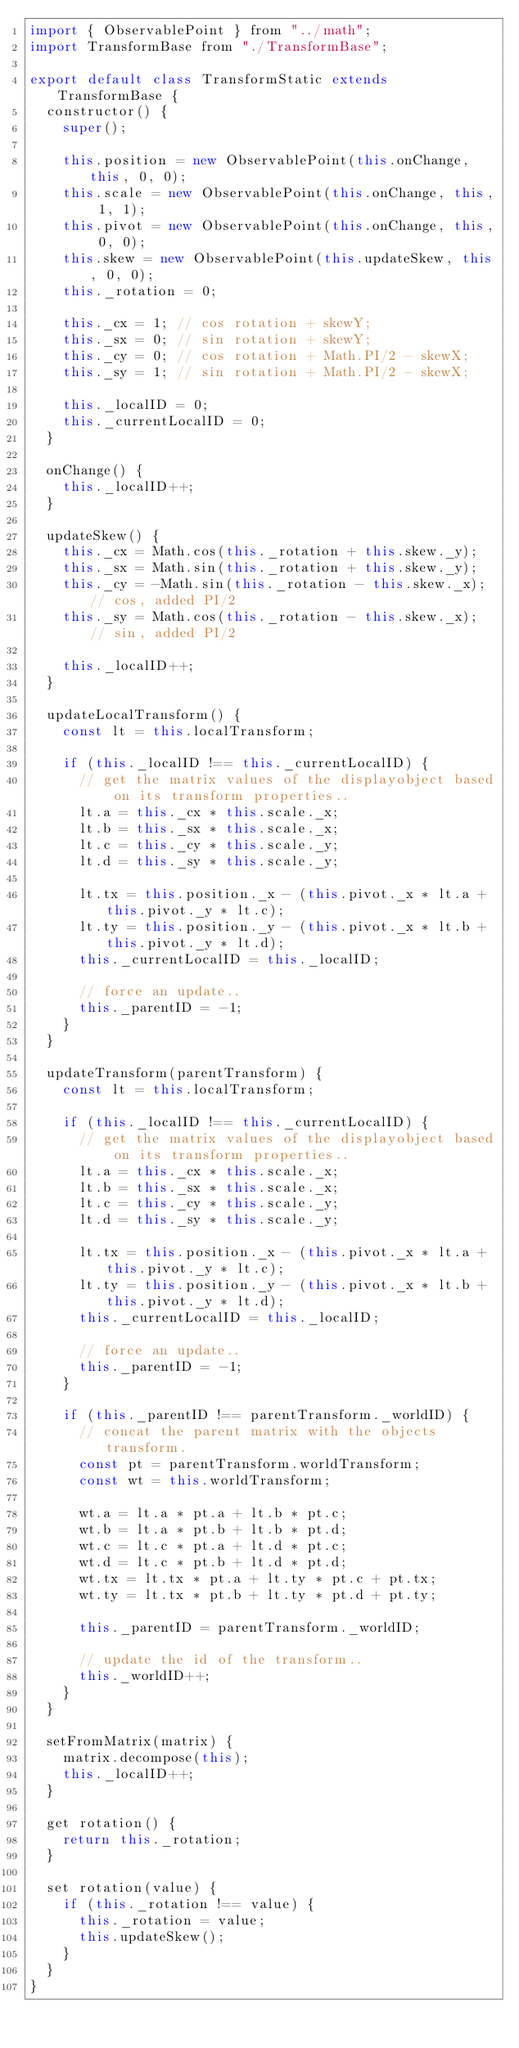<code> <loc_0><loc_0><loc_500><loc_500><_JavaScript_>import { ObservablePoint } from "../math";
import TransformBase from "./TransformBase";

export default class TransformStatic extends TransformBase {
  constructor() {
    super();

    this.position = new ObservablePoint(this.onChange, this, 0, 0);
    this.scale = new ObservablePoint(this.onChange, this, 1, 1);
    this.pivot = new ObservablePoint(this.onChange, this, 0, 0);
    this.skew = new ObservablePoint(this.updateSkew, this, 0, 0);
    this._rotation = 0;

    this._cx = 1; // cos rotation + skewY;
    this._sx = 0; // sin rotation + skewY;
    this._cy = 0; // cos rotation + Math.PI/2 - skewX;
    this._sy = 1; // sin rotation + Math.PI/2 - skewX;

    this._localID = 0;
    this._currentLocalID = 0;
  }

  onChange() {
    this._localID++;
  }

  updateSkew() {
    this._cx = Math.cos(this._rotation + this.skew._y);
    this._sx = Math.sin(this._rotation + this.skew._y);
    this._cy = -Math.sin(this._rotation - this.skew._x); // cos, added PI/2
    this._sy = Math.cos(this._rotation - this.skew._x); // sin, added PI/2

    this._localID++;
  }

  updateLocalTransform() {
    const lt = this.localTransform;

    if (this._localID !== this._currentLocalID) {
      // get the matrix values of the displayobject based on its transform properties..
      lt.a = this._cx * this.scale._x;
      lt.b = this._sx * this.scale._x;
      lt.c = this._cy * this.scale._y;
      lt.d = this._sy * this.scale._y;

      lt.tx = this.position._x - (this.pivot._x * lt.a + this.pivot._y * lt.c);
      lt.ty = this.position._y - (this.pivot._x * lt.b + this.pivot._y * lt.d);
      this._currentLocalID = this._localID;

      // force an update..
      this._parentID = -1;
    }
  }

  updateTransform(parentTransform) {
    const lt = this.localTransform;

    if (this._localID !== this._currentLocalID) {
      // get the matrix values of the displayobject based on its transform properties..
      lt.a = this._cx * this.scale._x;
      lt.b = this._sx * this.scale._x;
      lt.c = this._cy * this.scale._y;
      lt.d = this._sy * this.scale._y;

      lt.tx = this.position._x - (this.pivot._x * lt.a + this.pivot._y * lt.c);
      lt.ty = this.position._y - (this.pivot._x * lt.b + this.pivot._y * lt.d);
      this._currentLocalID = this._localID;

      // force an update..
      this._parentID = -1;
    }

    if (this._parentID !== parentTransform._worldID) {
      // concat the parent matrix with the objects transform.
      const pt = parentTransform.worldTransform;
      const wt = this.worldTransform;

      wt.a = lt.a * pt.a + lt.b * pt.c;
      wt.b = lt.a * pt.b + lt.b * pt.d;
      wt.c = lt.c * pt.a + lt.d * pt.c;
      wt.d = lt.c * pt.b + lt.d * pt.d;
      wt.tx = lt.tx * pt.a + lt.ty * pt.c + pt.tx;
      wt.ty = lt.tx * pt.b + lt.ty * pt.d + pt.ty;

      this._parentID = parentTransform._worldID;

      // update the id of the transform..
      this._worldID++;
    }
  }

  setFromMatrix(matrix) {
    matrix.decompose(this);
    this._localID++;
  }

  get rotation() {
    return this._rotation;
  }

  set rotation(value) {
    if (this._rotation !== value) {
      this._rotation = value;
      this.updateSkew();
    }
  }
}
</code> 